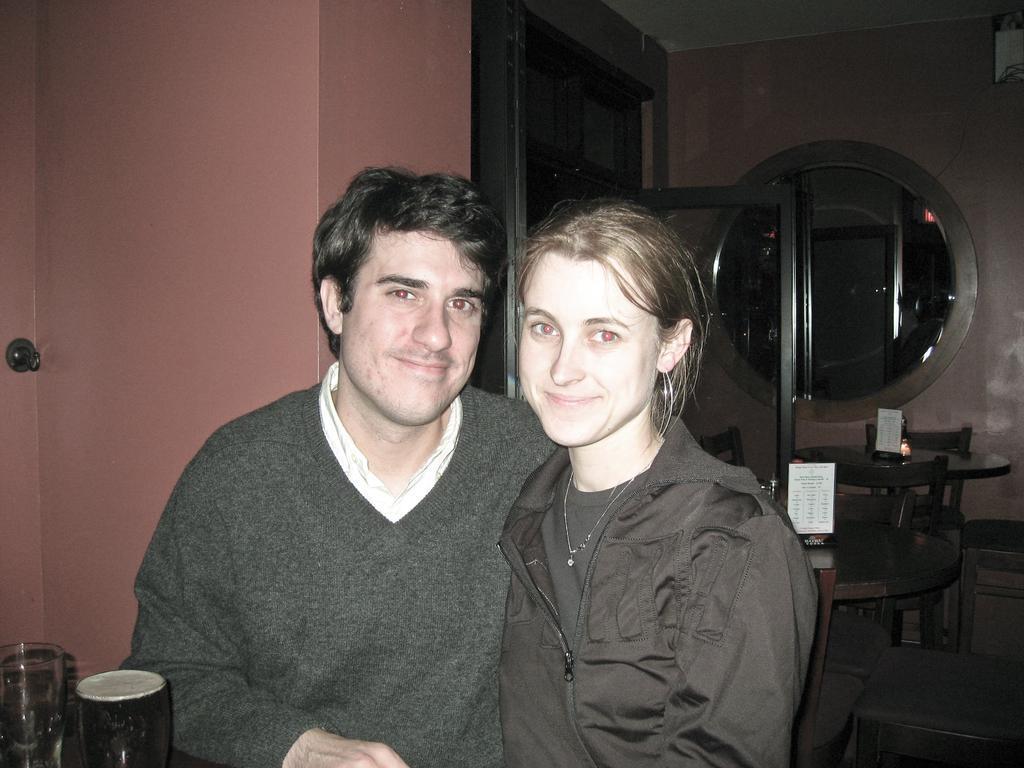Could you give a brief overview of what you see in this image? In this image I can see two persons. The person at right wearing black color dress and the person at left wearing gray and white color dress, I can also see few glass. Background I can see a glass window and the wall is in peach color. 